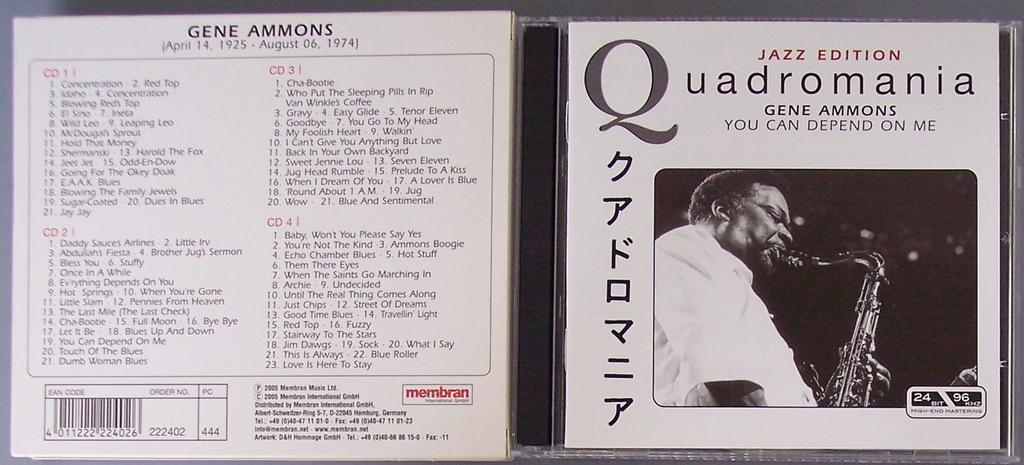Please provide a concise description of this image. This is a black and white image. In this image we can see a disc cover and on the cover we can see some text, bar code and a person playing musical instrument. 